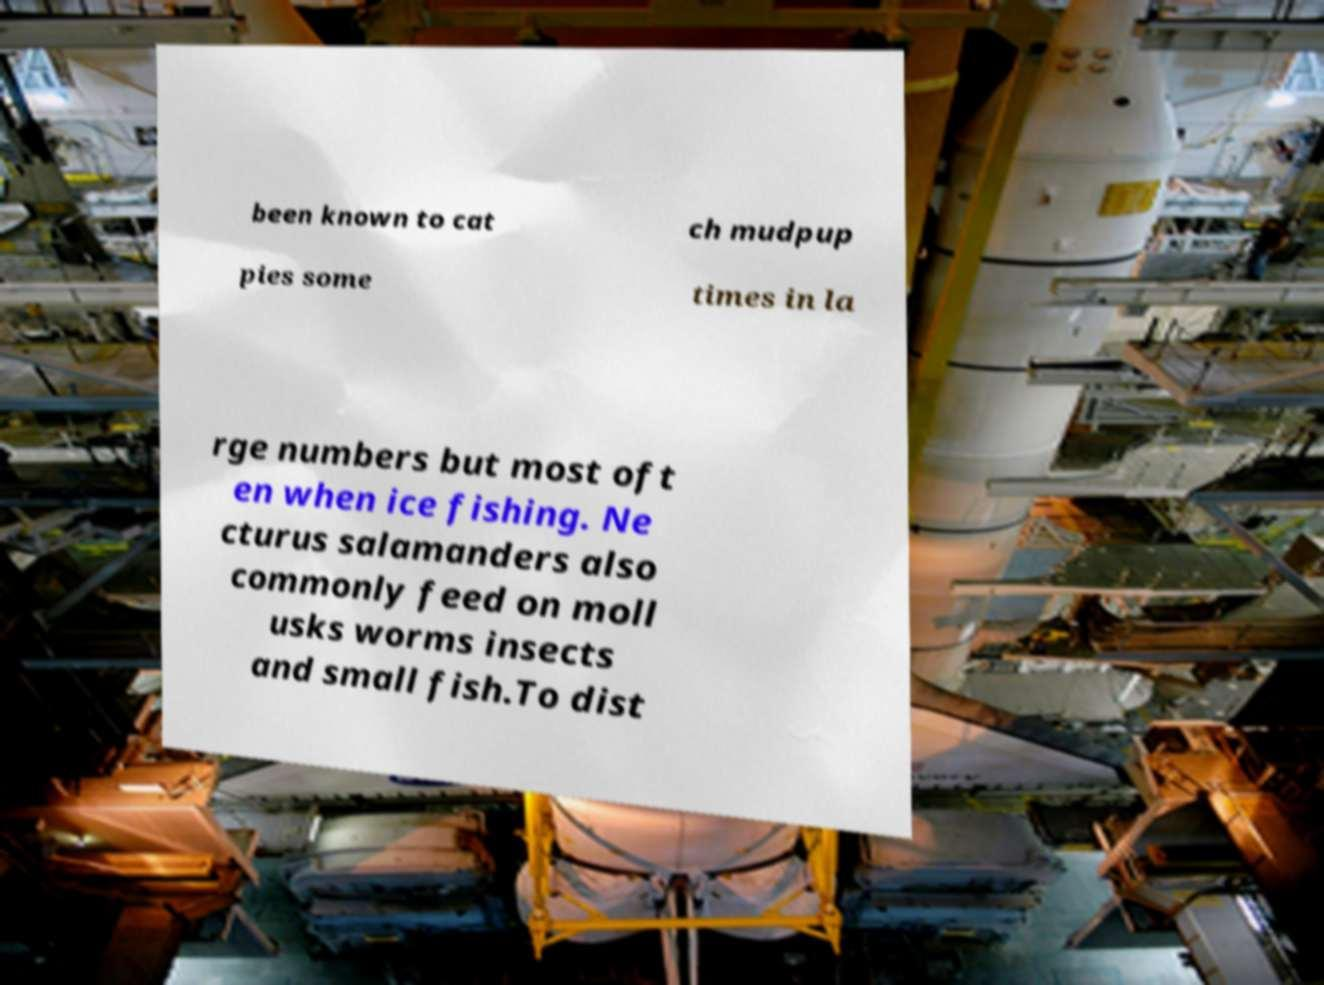Could you assist in decoding the text presented in this image and type it out clearly? been known to cat ch mudpup pies some times in la rge numbers but most oft en when ice fishing. Ne cturus salamanders also commonly feed on moll usks worms insects and small fish.To dist 